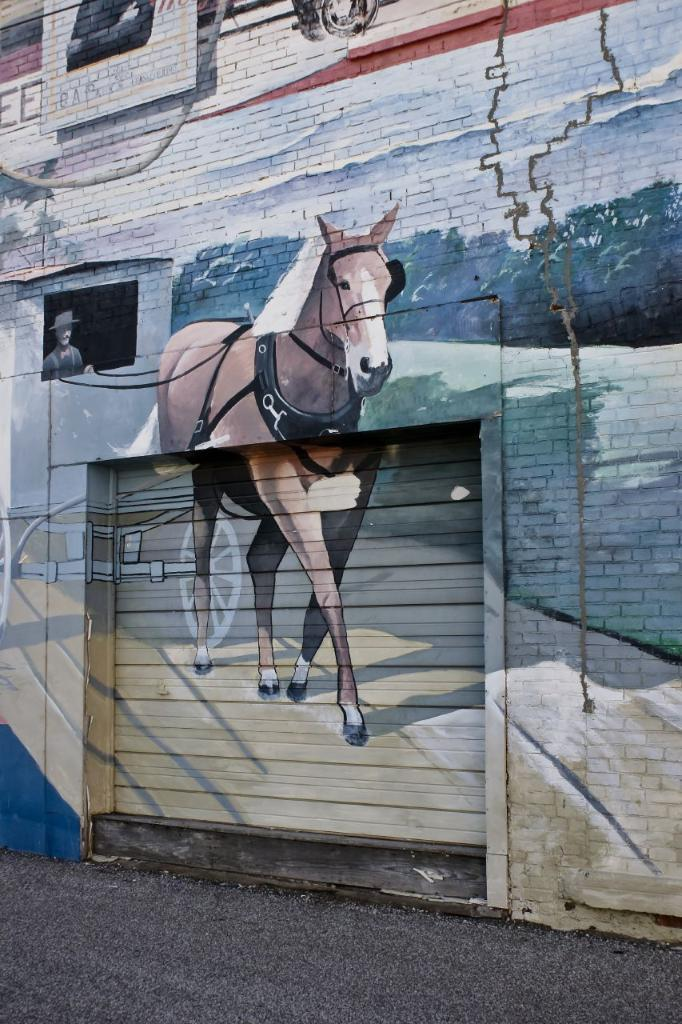What is depicted on the wall of the building in the image? There is a painting on the wall of the building. What type of animal is present in the image? There is a horse in the image. Who or what else is present in the image? There is a person and a cart in the image. What can be seen at the top of the image? There is a vehicle at the top of the image. What type of force is being applied to the yam in the image? There is no yam present in the image, so it is not possible to determine what type of force might be applied to it. 